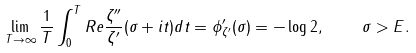<formula> <loc_0><loc_0><loc_500><loc_500>\lim _ { T \to \infty } \frac { 1 } { T } \int _ { 0 } ^ { T } R e \frac { \zeta ^ { \prime \prime } } { \zeta ^ { \prime } } ( \sigma + i t ) d t = \phi _ { \zeta ^ { \prime } } ^ { \prime } ( \sigma ) = - \log 2 , \quad \sigma > E .</formula> 